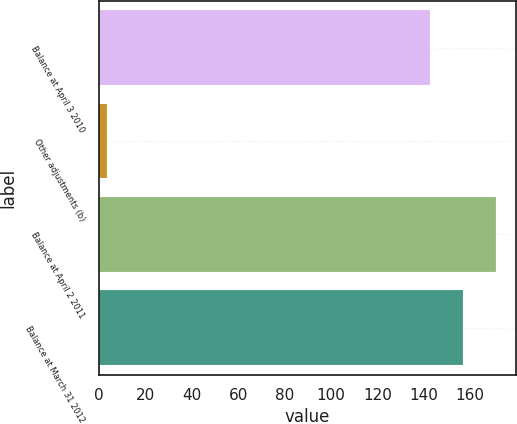Convert chart. <chart><loc_0><loc_0><loc_500><loc_500><bar_chart><fcel>Balance at April 3 2010<fcel>Other adjustments (b)<fcel>Balance at April 2 2011<fcel>Balance at March 31 2012<nl><fcel>142.5<fcel>3.3<fcel>171<fcel>156.75<nl></chart> 